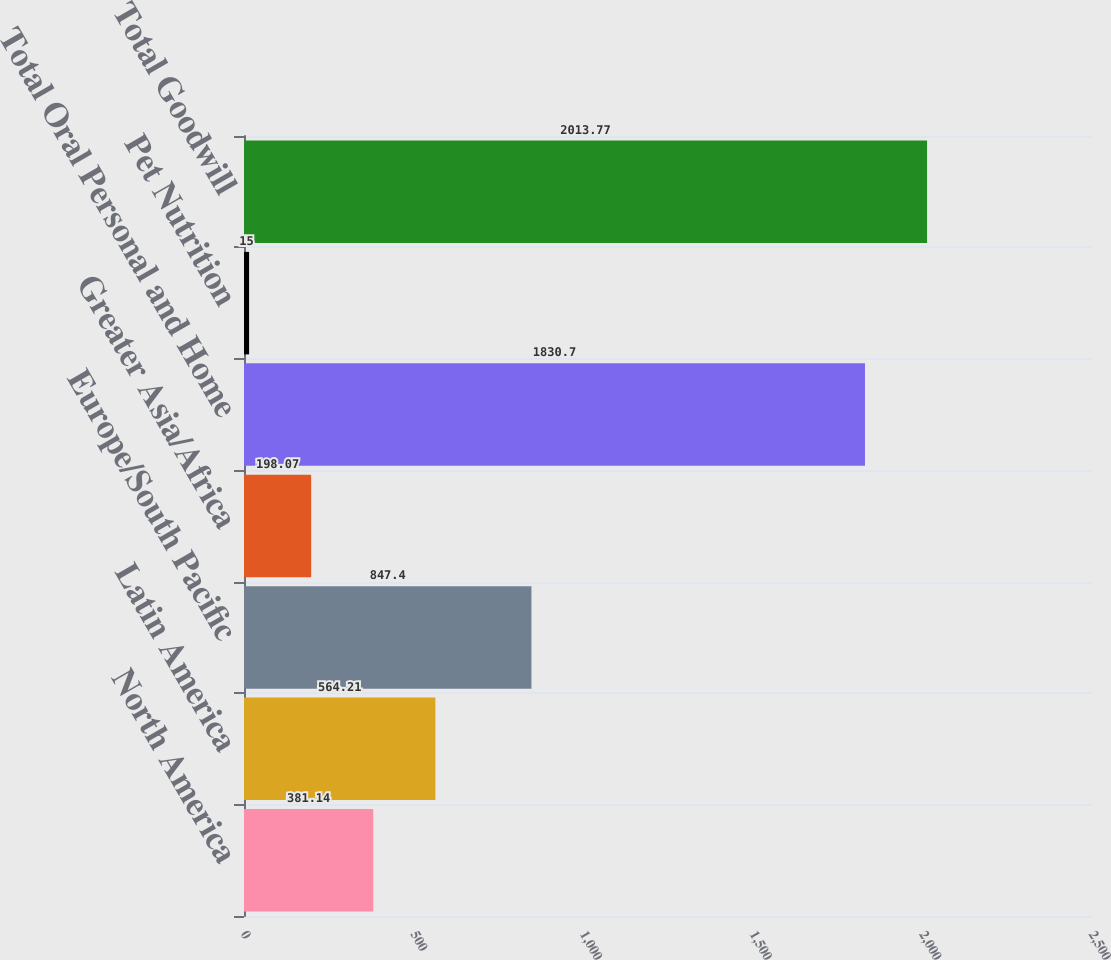Convert chart to OTSL. <chart><loc_0><loc_0><loc_500><loc_500><bar_chart><fcel>North America<fcel>Latin America<fcel>Europe/South Pacific<fcel>Greater Asia/Africa<fcel>Total Oral Personal and Home<fcel>Pet Nutrition<fcel>Total Goodwill<nl><fcel>381.14<fcel>564.21<fcel>847.4<fcel>198.07<fcel>1830.7<fcel>15<fcel>2013.77<nl></chart> 